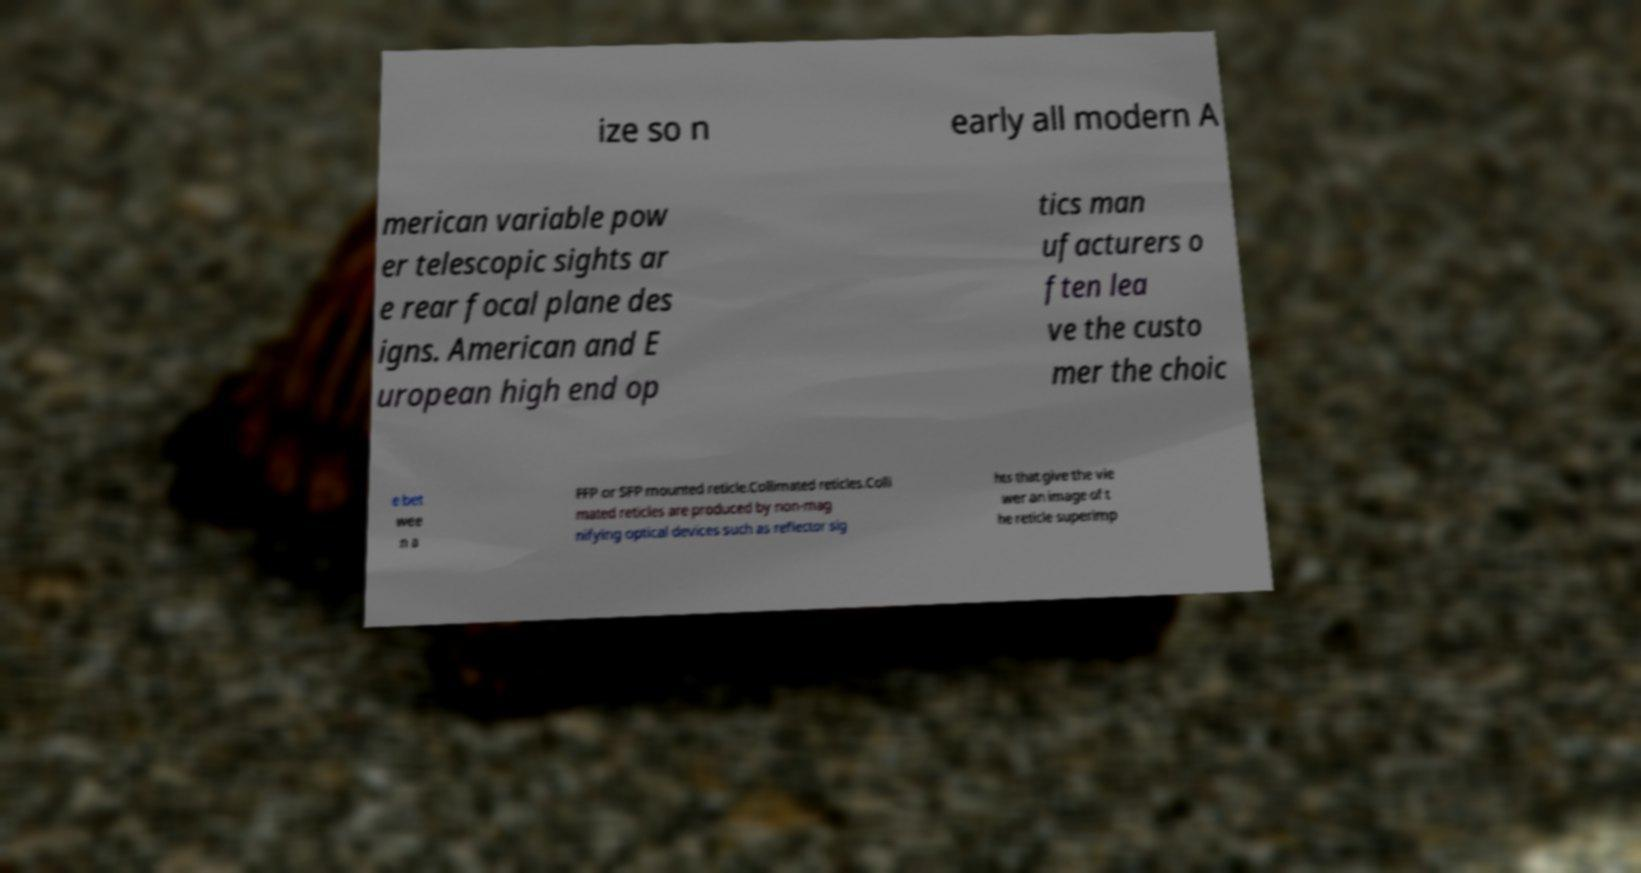Please identify and transcribe the text found in this image. ize so n early all modern A merican variable pow er telescopic sights ar e rear focal plane des igns. American and E uropean high end op tics man ufacturers o ften lea ve the custo mer the choic e bet wee n a FFP or SFP mounted reticle.Collimated reticles.Colli mated reticles are produced by non-mag nifying optical devices such as reflector sig hts that give the vie wer an image of t he reticle superimp 